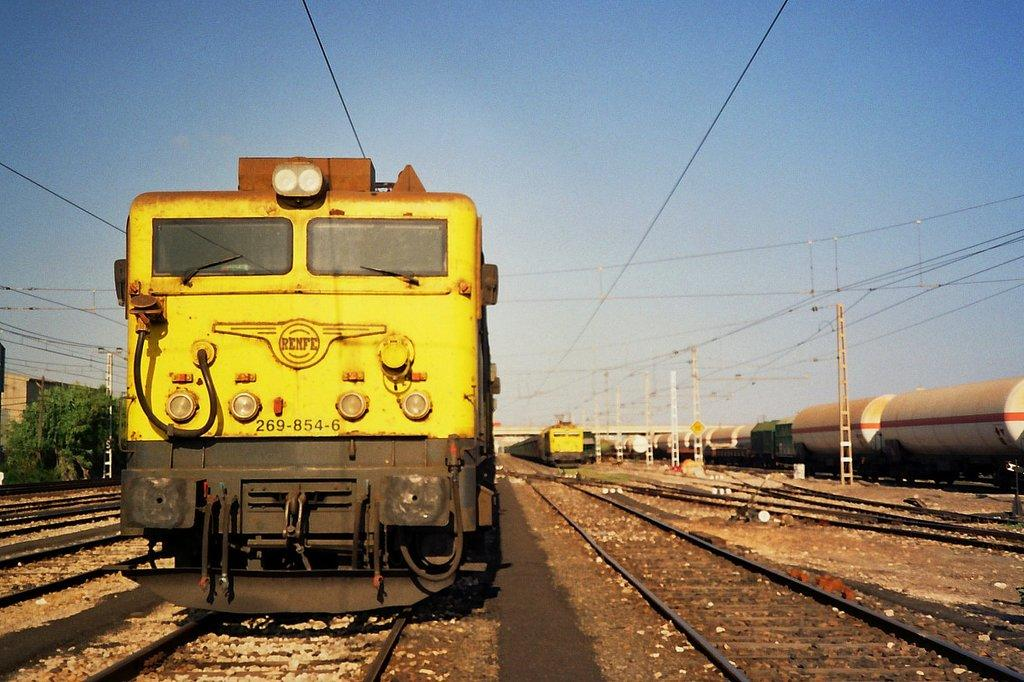What is the main subject of the image? The main subject of the image is trains. What are the trains doing in the image? The trains are moving on a track. What can be seen in the background of the image? There are trees visible in the image. Are there any structures present in the image? Yes, there is at least one building in the image. What type of veil is being worn by the train in the image? There is no veil present in the image, as it features trains moving on a track. What is the relationship between the train and the trees in the image? There is no direct relationship between the train and the trees in the image; they are simply elements present in the same scene. 